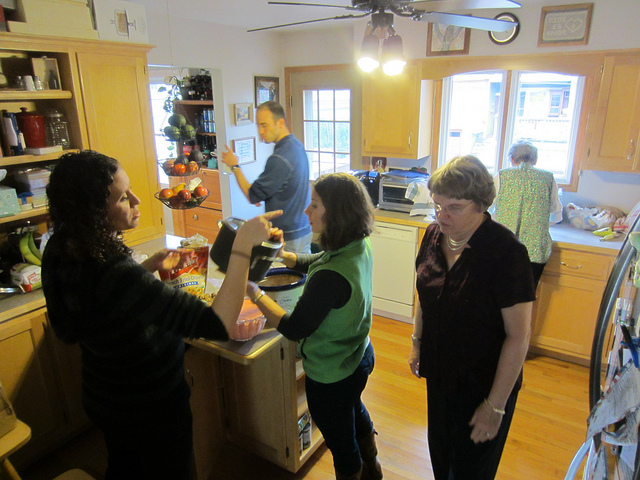<image>What dessert is the lady serving? I am not sure which dessert the lady is serving. It can be cake, fruit, pie, or chips. What dessert is the lady serving? I am not sure what dessert is the lady serving. It can be seen cake, fruit, pie or chips. 